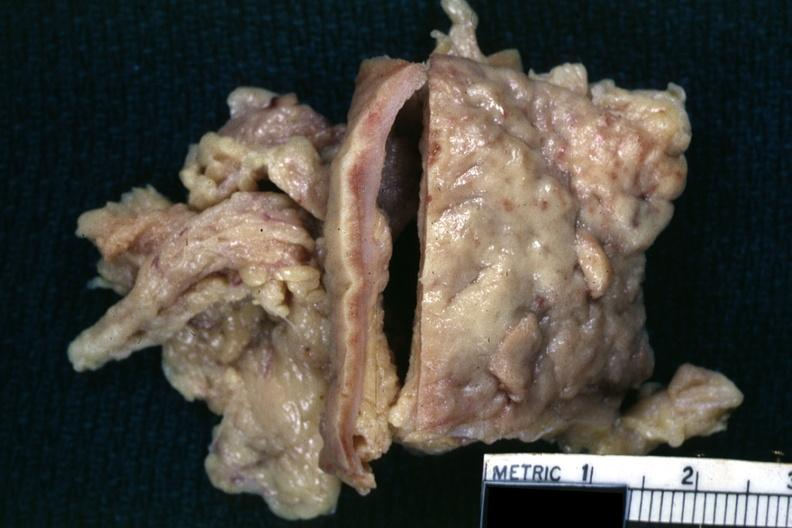s abdomen present?
Answer the question using a single word or phrase. Yes 